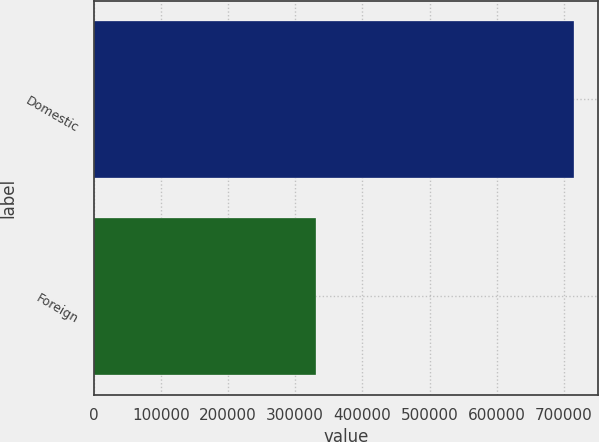Convert chart to OTSL. <chart><loc_0><loc_0><loc_500><loc_500><bar_chart><fcel>Domestic<fcel>Foreign<nl><fcel>714723<fcel>331263<nl></chart> 